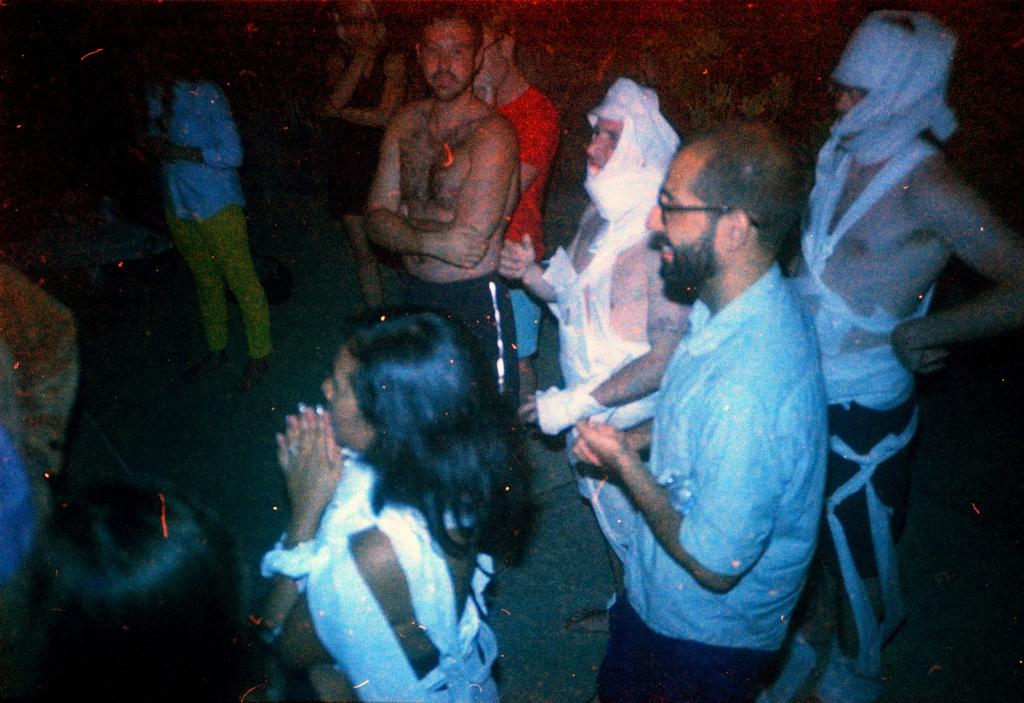How many people are in the image? There is a group of people in the image. What are the people in the image doing? The people are standing. What can be observed about the background of the image? The background of the image is dark. What type of cloth is being used to make a camp in the image? There is no camp or cloth present in the image. Are the people wearing boots in the image? The image does not show the people's footwear, so it cannot be determined if they are wearing boots. 